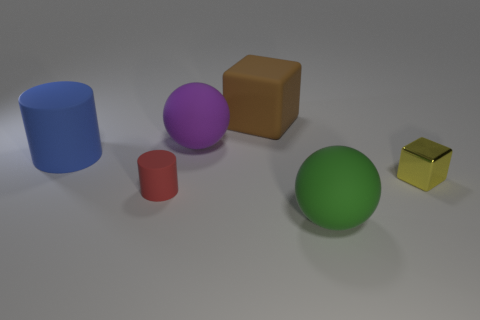How many objects are there in the image? There are five distinct objects visible in the image: a blue cylinder, a purple sphere, a brown cube, a red cup, and a smaller yellow cube. 